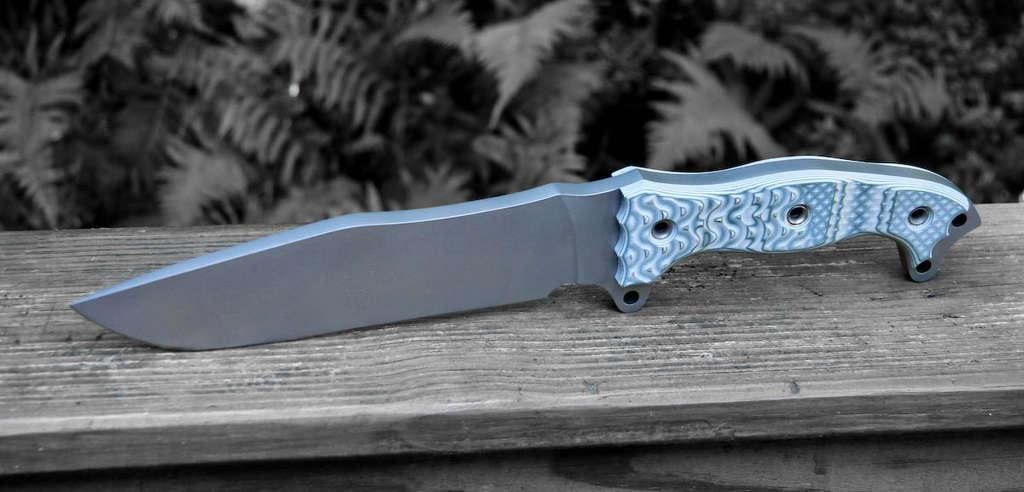What type of surface is at the bottom of the image? There is a wooden surface at the bottom of the image. What object is placed on the wooden surface? There is a knife on the wooden surface. What can be seen at the top of the image? There are leaves visible at the top of the image. Where is the toothbrush located in the image? There is no toothbrush present in the image. Can you tell me what type of club the fireman is holding in the image? There is no fireman or club present in the image. 